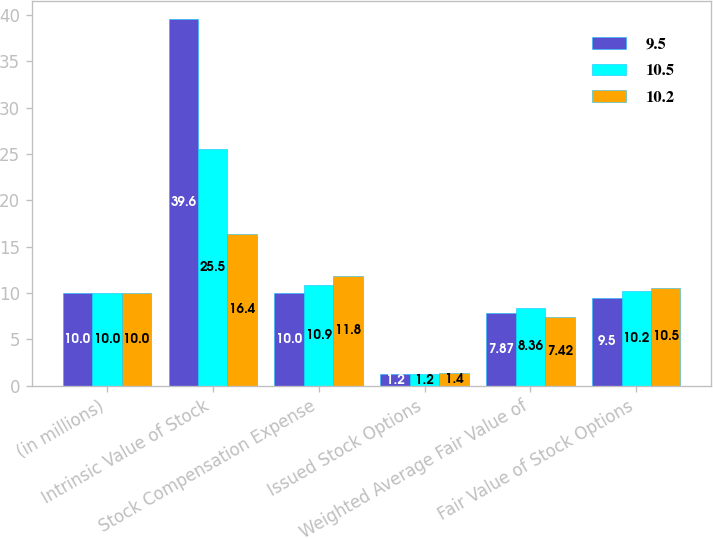Convert chart. <chart><loc_0><loc_0><loc_500><loc_500><stacked_bar_chart><ecel><fcel>(in millions)<fcel>Intrinsic Value of Stock<fcel>Stock Compensation Expense<fcel>Issued Stock Options<fcel>Weighted Average Fair Value of<fcel>Fair Value of Stock Options<nl><fcel>9.5<fcel>10<fcel>39.6<fcel>10<fcel>1.2<fcel>7.87<fcel>9.5<nl><fcel>10.5<fcel>10<fcel>25.5<fcel>10.9<fcel>1.2<fcel>8.36<fcel>10.2<nl><fcel>10.2<fcel>10<fcel>16.4<fcel>11.8<fcel>1.4<fcel>7.42<fcel>10.5<nl></chart> 